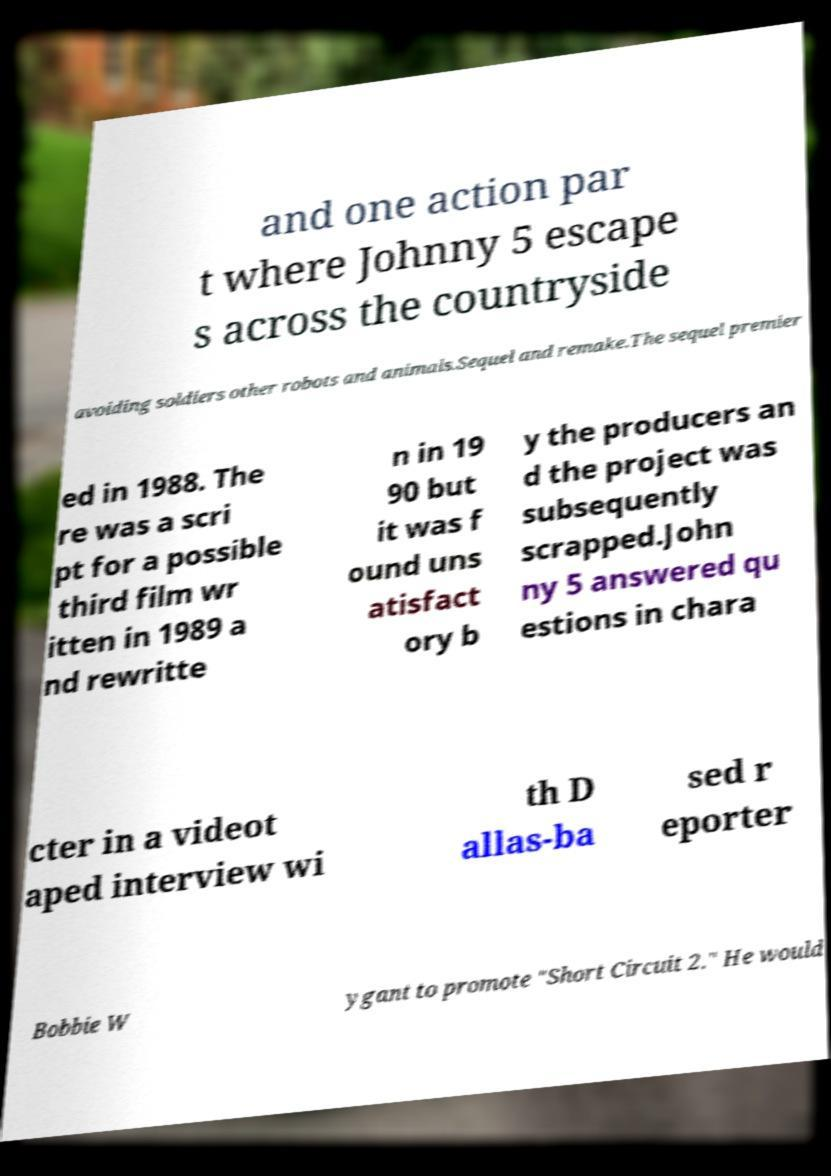I need the written content from this picture converted into text. Can you do that? and one action par t where Johnny 5 escape s across the countryside avoiding soldiers other robots and animals.Sequel and remake.The sequel premier ed in 1988. The re was a scri pt for a possible third film wr itten in 1989 a nd rewritte n in 19 90 but it was f ound uns atisfact ory b y the producers an d the project was subsequently scrapped.John ny 5 answered qu estions in chara cter in a videot aped interview wi th D allas-ba sed r eporter Bobbie W ygant to promote "Short Circuit 2." He would 